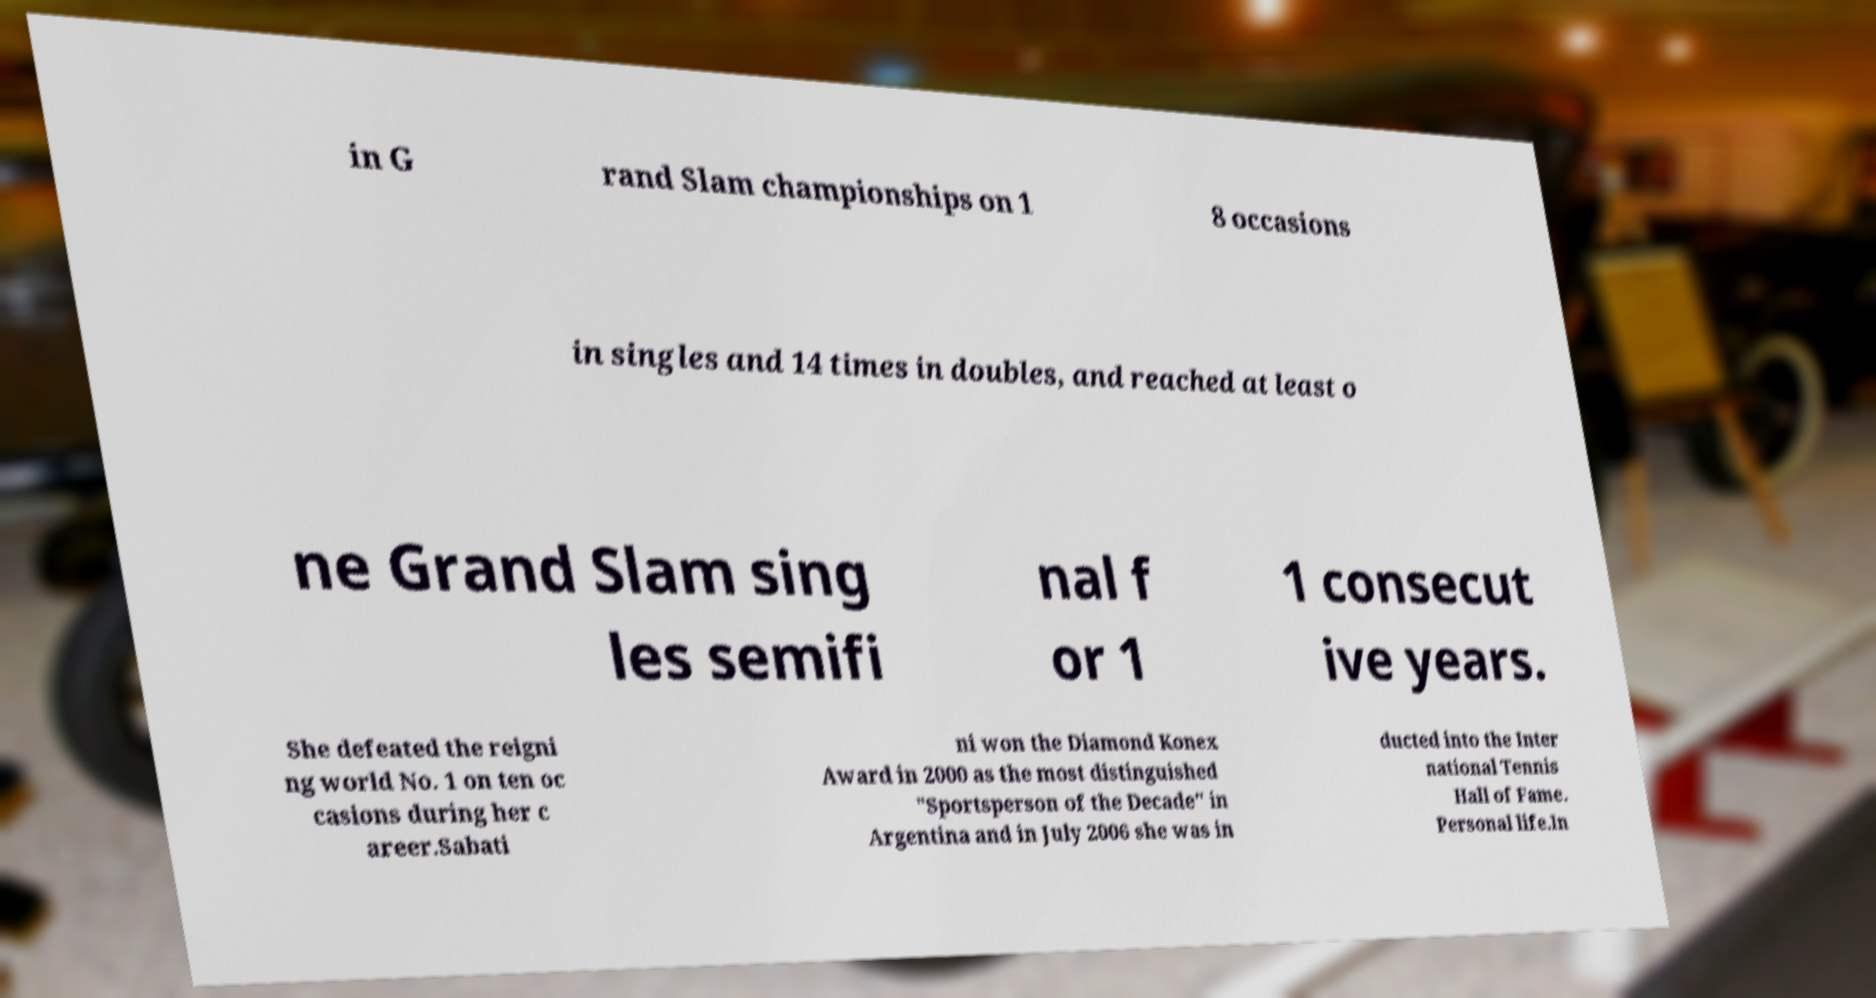Could you extract and type out the text from this image? in G rand Slam championships on 1 8 occasions in singles and 14 times in doubles, and reached at least o ne Grand Slam sing les semifi nal f or 1 1 consecut ive years. She defeated the reigni ng world No. 1 on ten oc casions during her c areer.Sabati ni won the Diamond Konex Award in 2000 as the most distinguished "Sportsperson of the Decade" in Argentina and in July 2006 she was in ducted into the Inter national Tennis Hall of Fame. Personal life.In 